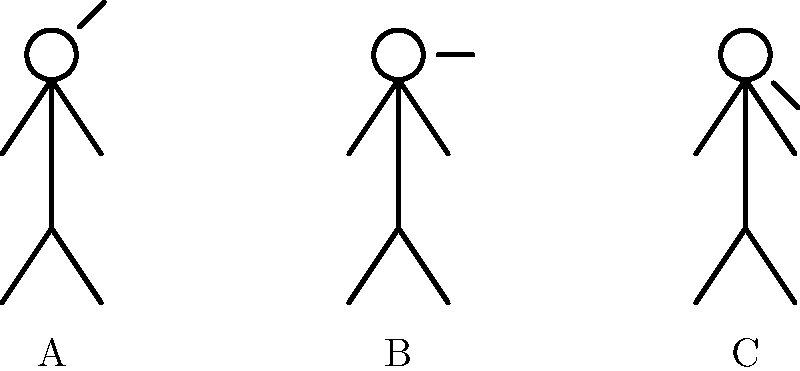As a sports psychologist working with a catcher, which of the stick figure pitchers (A, B, or C) is likely displaying the most confidence based on their body language? To interpret the body language of pitchers using stick figure illustrations, we need to consider the following steps:

1. Analyze posture: An upright, open posture generally indicates confidence.
2. Observe arm position: Arms held away from the body suggest openness and confidence.
3. Check head position: A raised chin often signifies confidence and assertiveness.

Examining each stick figure:

A: The figure has a slightly angled arm position (45 degrees), suggesting a moderate level of openness and confidence.

B: The figure has a neutral arm position (0 degrees), which may indicate a balanced or neutral emotional state.

C: The figure has a downward angled arm position (-45 degrees), which could suggest a closed-off or less confident posture.

Based on these observations, stick figure A displays the most open and confident body language among the three options. The upward angle of the arms indicates a more expansive and assertive posture, which is often associated with higher levels of confidence.

As a sports psychologist, it's important to note that body language is just one aspect of a pitcher's mental state. Other factors, such as facial expressions, breathing patterns, and overall performance, should also be considered when assessing a pitcher's confidence level.
Answer: A 